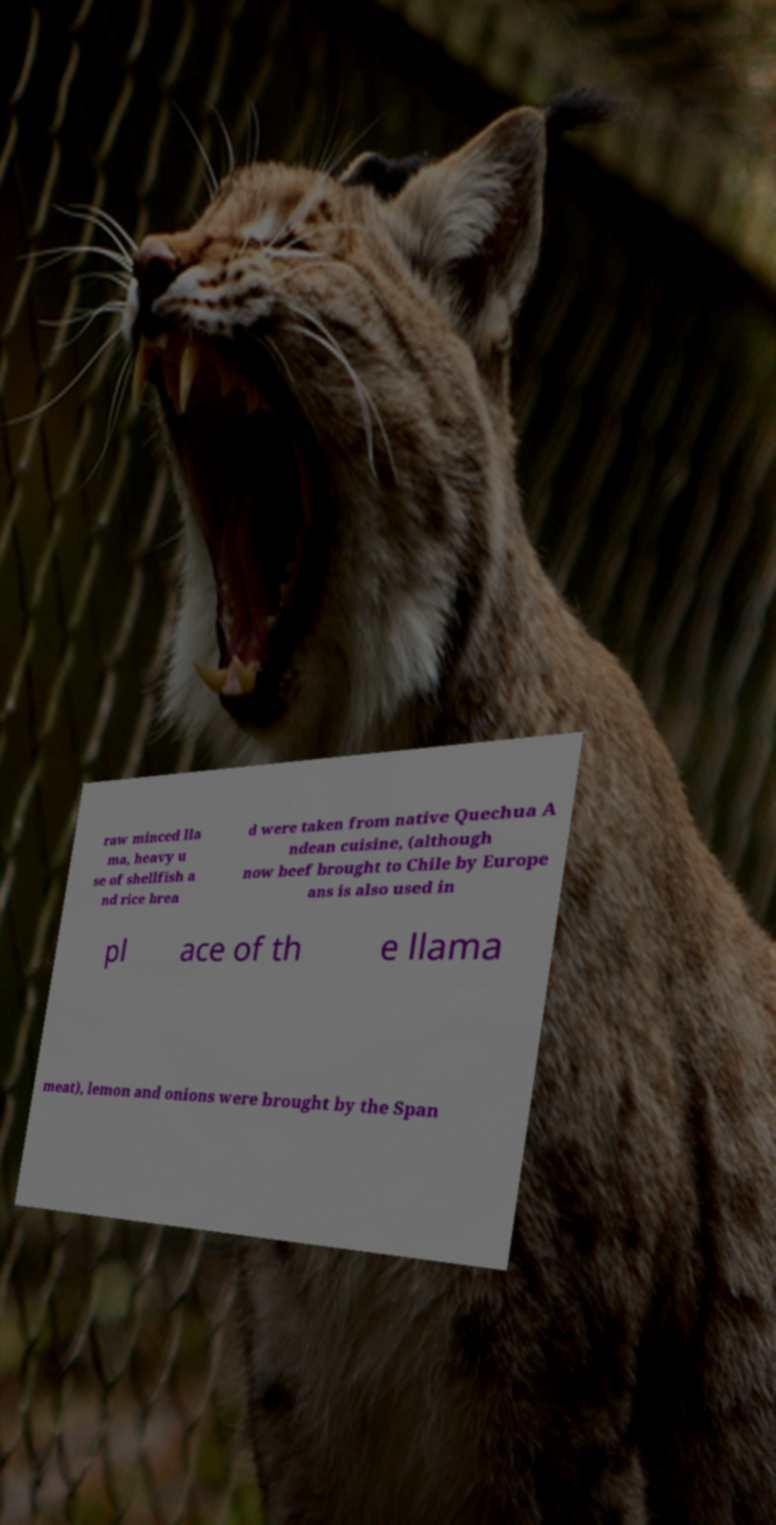For documentation purposes, I need the text within this image transcribed. Could you provide that? raw minced lla ma, heavy u se of shellfish a nd rice brea d were taken from native Quechua A ndean cuisine, (although now beef brought to Chile by Europe ans is also used in pl ace of th e llama meat), lemon and onions were brought by the Span 